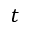<formula> <loc_0><loc_0><loc_500><loc_500>t</formula> 